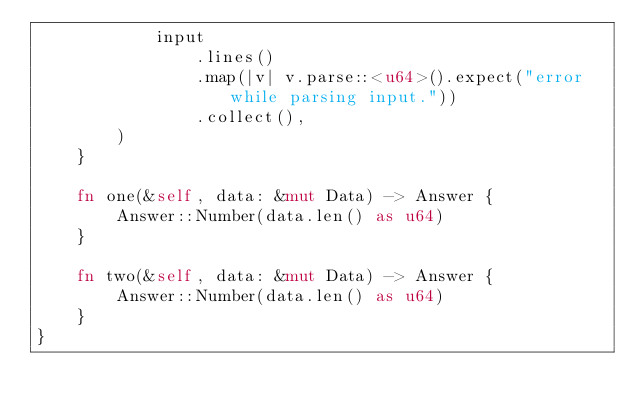Convert code to text. <code><loc_0><loc_0><loc_500><loc_500><_Rust_>            input
                .lines()
                .map(|v| v.parse::<u64>().expect("error while parsing input."))
                .collect(),
        )
    }

    fn one(&self, data: &mut Data) -> Answer {
        Answer::Number(data.len() as u64)
    }

    fn two(&self, data: &mut Data) -> Answer {
        Answer::Number(data.len() as u64)
    }
}
</code> 